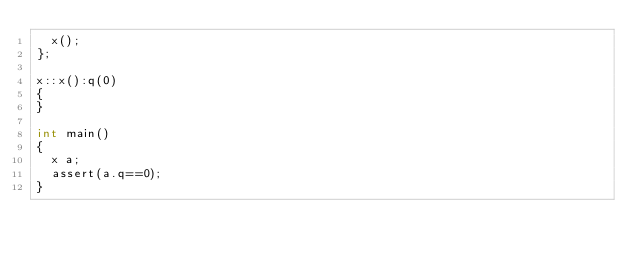Convert code to text. <code><loc_0><loc_0><loc_500><loc_500><_C++_>  x();
};

x::x():q(0)
{
}

int main()
{
  x a;
  assert(a.q==0);
}
</code> 